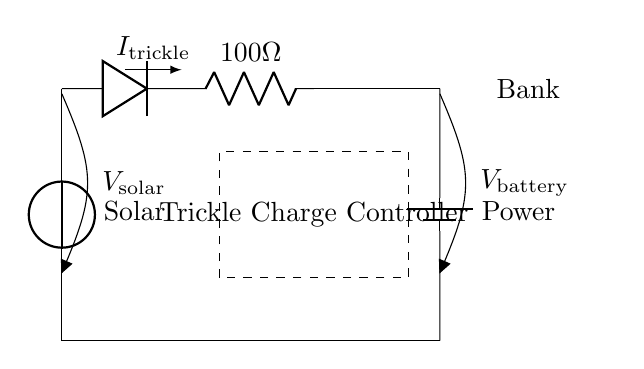What is the source of power in this circuit? The source of power is the solar panel, indicated by the voltage source labeled "Solar".
Answer: Solar panel What is the purpose of the diode in this circuit? The diode allows current to flow in one direction, preventing any potential reverse current from damaging the solar panel or the battery.
Answer: Current direction control What is the resistance value in the circuit? The circuit includes a current limiting resistor valued at 100 ohms, as labeled near the resistor symbol.
Answer: 100 ohms What does the dashed box represent? The dashed box labeled "Trickle Charge Controller" represents a component that regulates the charging current to the battery, ensuring safe and efficient charging.
Answer: Trickle Charge Controller How does trickle charging benefit the power bank? Trickle charging maintains the power bank’s charge slowly over time, preventing overcharging and extending the lifespan of the battery.
Answer: Extends battery lifespan What current flows through the circuit during trickle charging? The current flowing during trickle charging is denoted as "I_trickle", indicating the specific current value but not providing a numerical value in the diagram.
Answer: I_trickle What is the overall function of this circuit? The overall function of this circuit is to maintain a backup power bank charged using solar energy during slow business hours.
Answer: Maintain backup power bank charge 